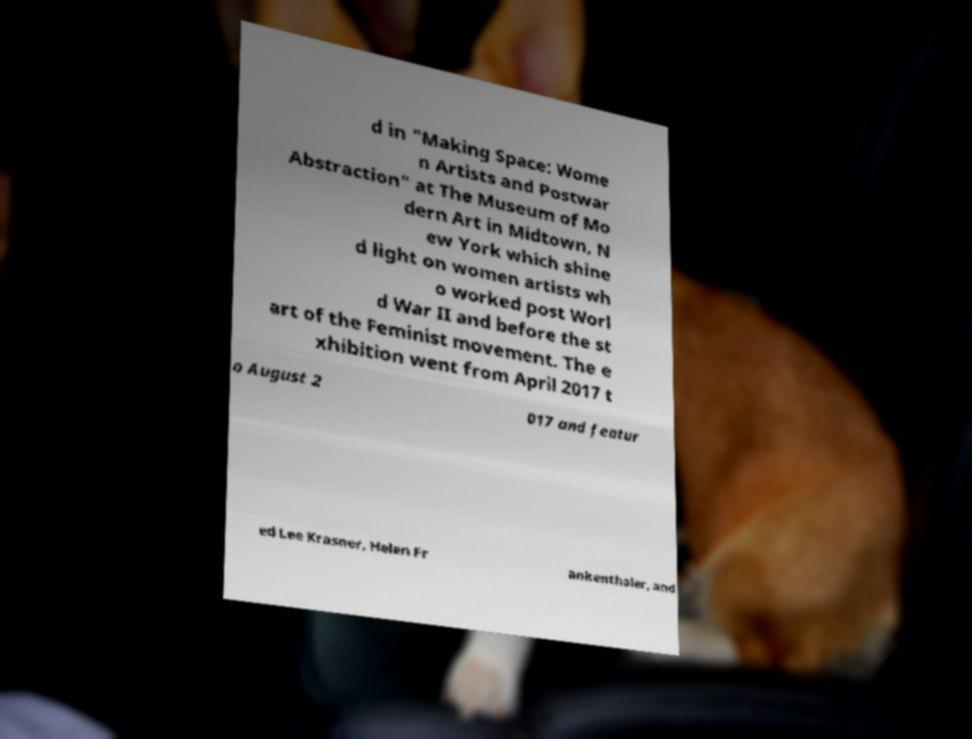I need the written content from this picture converted into text. Can you do that? d in "Making Space: Wome n Artists and Postwar Abstraction" at The Museum of Mo dern Art in Midtown, N ew York which shine d light on women artists wh o worked post Worl d War II and before the st art of the Feminist movement. The e xhibition went from April 2017 t o August 2 017 and featur ed Lee Krasner, Helen Fr ankenthaler, and 